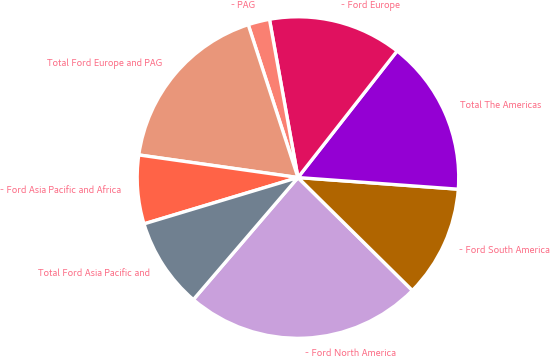Convert chart. <chart><loc_0><loc_0><loc_500><loc_500><pie_chart><fcel>- Ford North America<fcel>- Ford South America<fcel>Total The Americas<fcel>- Ford Europe<fcel>- PAG<fcel>Total Ford Europe and PAG<fcel>- Ford Asia Pacific and Africa<fcel>Total Ford Asia Pacific and<nl><fcel>23.88%<fcel>11.24%<fcel>15.58%<fcel>13.41%<fcel>2.17%<fcel>17.75%<fcel>6.9%<fcel>9.07%<nl></chart> 